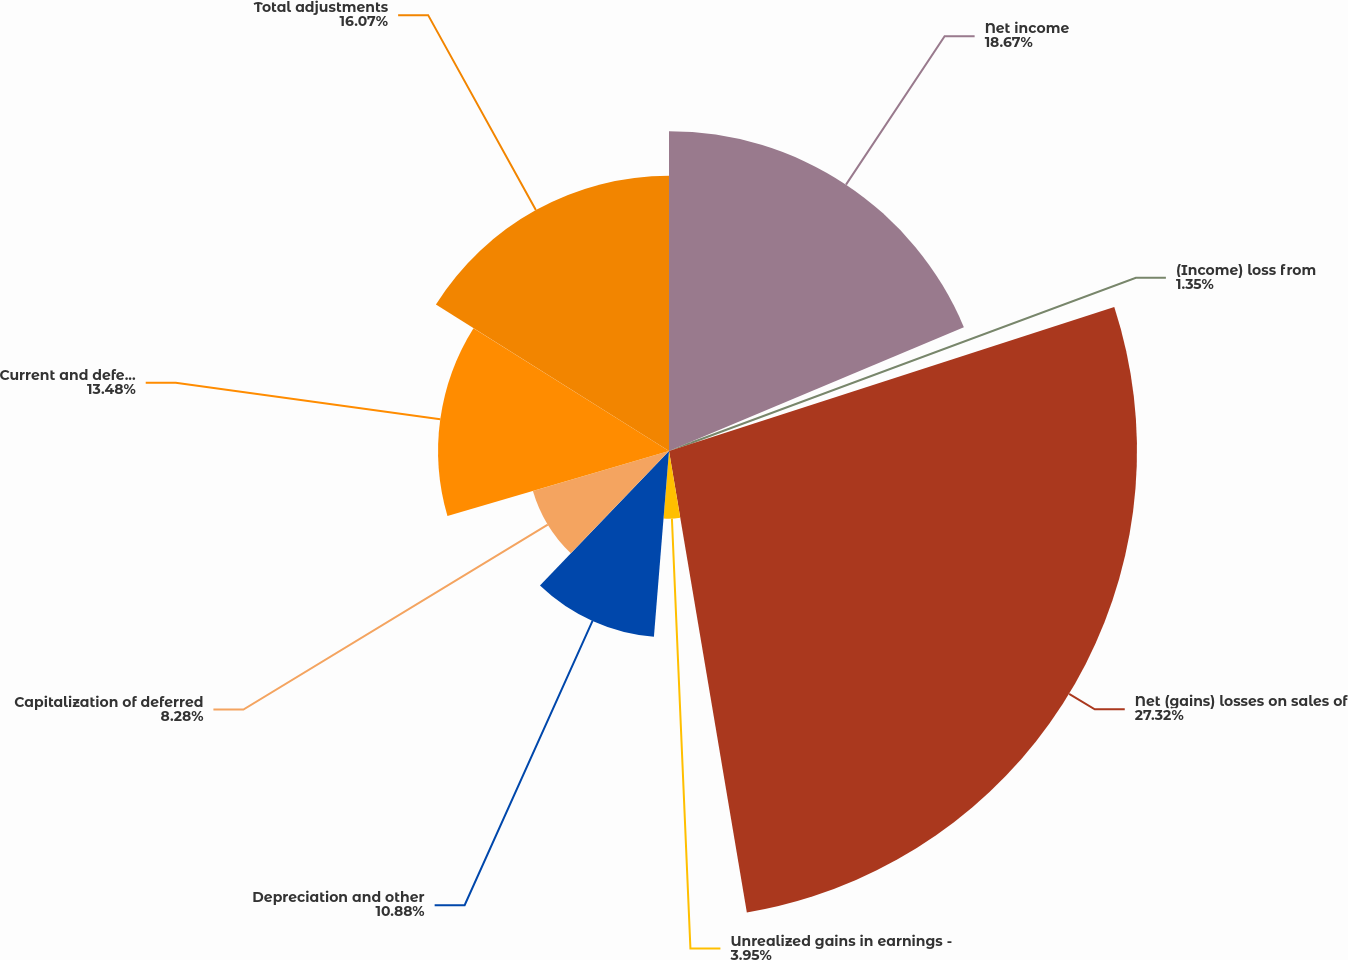Convert chart. <chart><loc_0><loc_0><loc_500><loc_500><pie_chart><fcel>Net income<fcel>(Income) loss from<fcel>Net (gains) losses on sales of<fcel>Unrealized gains in earnings -<fcel>Depreciation and other<fcel>Capitalization of deferred<fcel>Current and deferred income<fcel>Total adjustments<nl><fcel>18.67%<fcel>1.35%<fcel>27.32%<fcel>3.95%<fcel>10.88%<fcel>8.28%<fcel>13.48%<fcel>16.07%<nl></chart> 